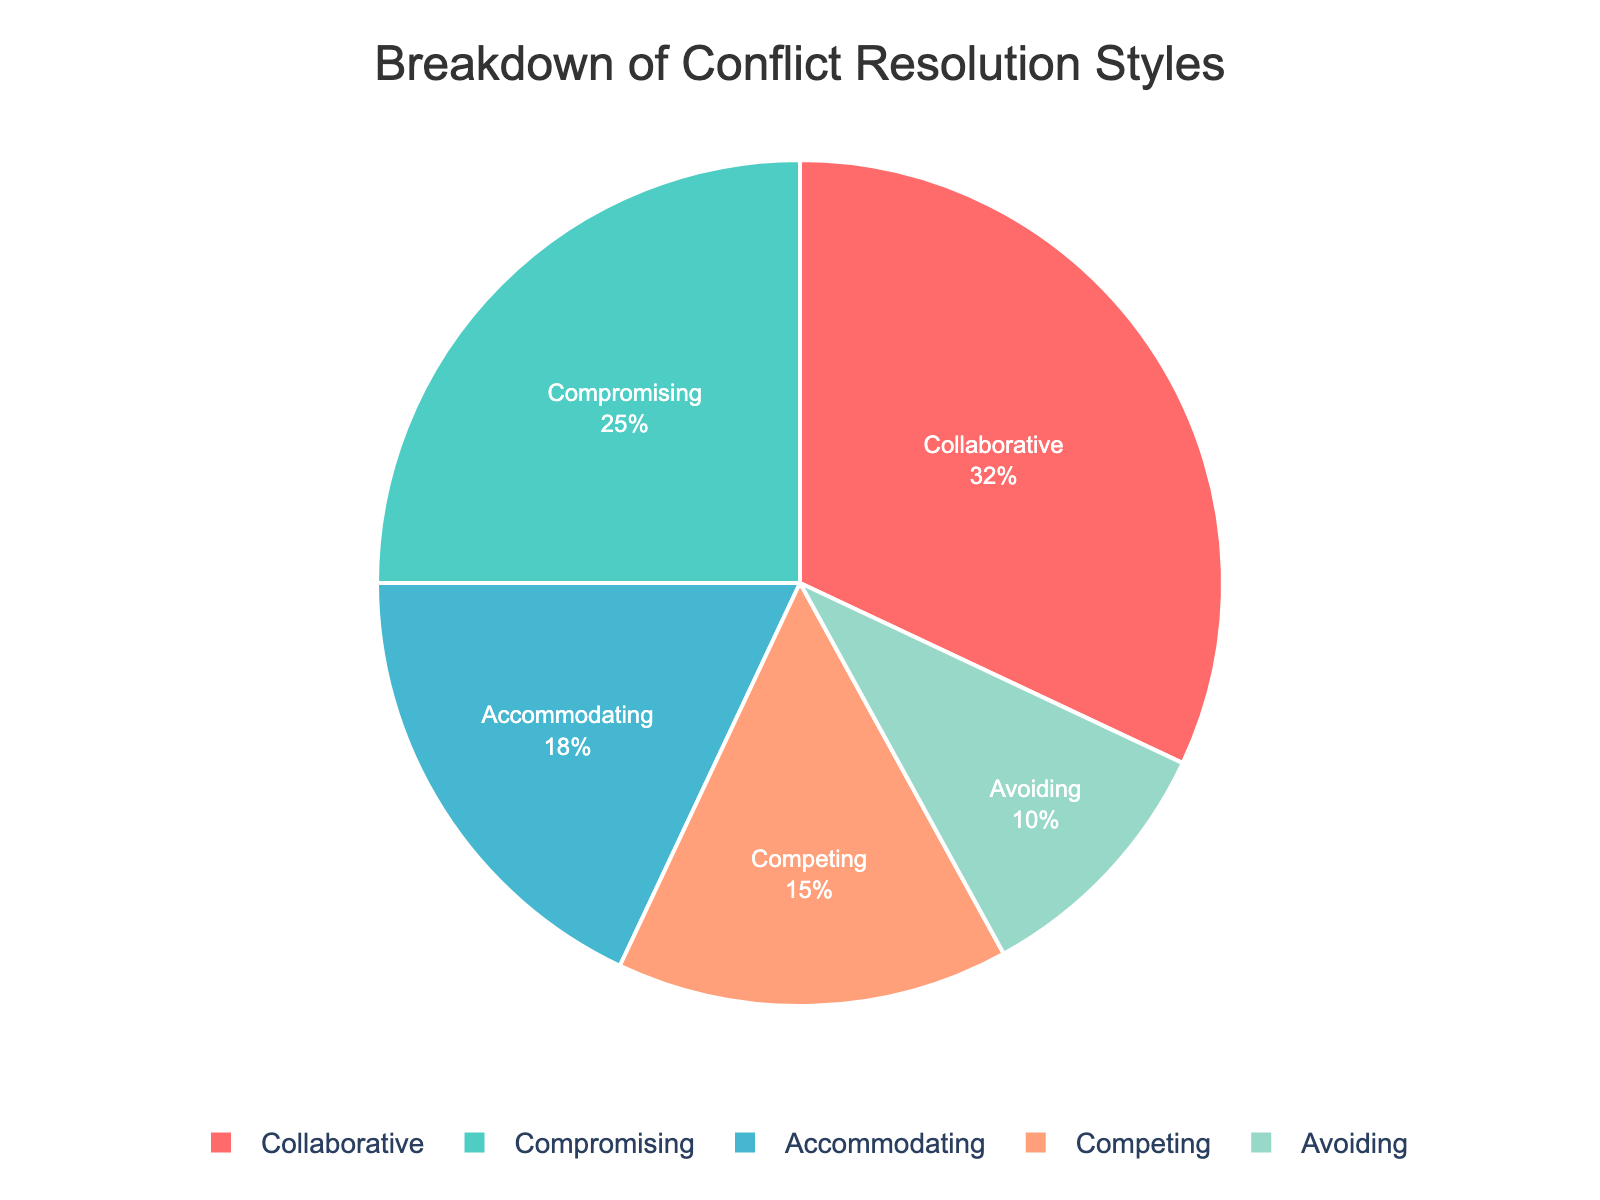What's the most common conflict resolution style among team members? From the pie chart, the largest section represents the most prevalent conflict resolution style. The "Collaborative" style has the largest slice.
Answer: Collaborative What percentage of team members use a "Compromising" style? Look at the section labeled "Compromising" in the pie chart and refer to the percentage indicated. The "Compromising" style shows 25%.
Answer: 25% Which conflict resolution style is least common among team members? Find the smallest slice in the pie chart, which corresponds to the least common style. The "Avoiding" style is the smallest.
Answer: Avoiding How much larger is the percentage of "Collaborative" style compared to "Competing"? Subtract the percentage of the "Competing" style from that of the "Collaborative" style: 32% - 15% = 17%.
Answer: 17% Do "Compromising" and "Accommodating" styles combined make up more than half of the team's conflict resolution styles? Add the percentages of "Compromising" (25%) and "Accommodating" (18%) styles: 25% + 18% = 43%. Since 43% is less than 50%, they do not make up more than half.
Answer: No Rank the conflict resolution styles from most to least common. List the styles in order from the largest percentage to the smallest: 1) Collaborative (32%), 2) Compromising (25%), 3) Accommodating (18%), 4) Competing (15%), 5) Avoiding (10%).
Answer: Collaborative, Compromising, Accommodating, Competing, Avoiding What is the combined percentage of "Collaborative" and "Avoiding" styles? Add the percentages of "Collaborative" (32%) and "Avoiding" (10%): 32% + 10% = 42%.
Answer: 42% Which conflict resolution styles together make up exactly half of the team's preferences? Identify the styles that sum up to 50%: "Collaborative" (32%) and "Compromising" (18%) together: 32% + 18% = 50%.
Answer: Collaborative and Compromising How does the percentage of "Accommodating" style compare to "Competing"? Compare the percentages directly: "Accommodating" is 18% and "Competing" is 15%. Since 18% > 15%, "Accommodating" is more common than "Competing".
Answer: Accommodating is more common If you group "Collaborative" and "Compromising" styles together, what percentage do they represent? Add the percentages of "Collaborative" (32%) and "Compromising" (25%): 32% + 25% = 57%.
Answer: 57% 